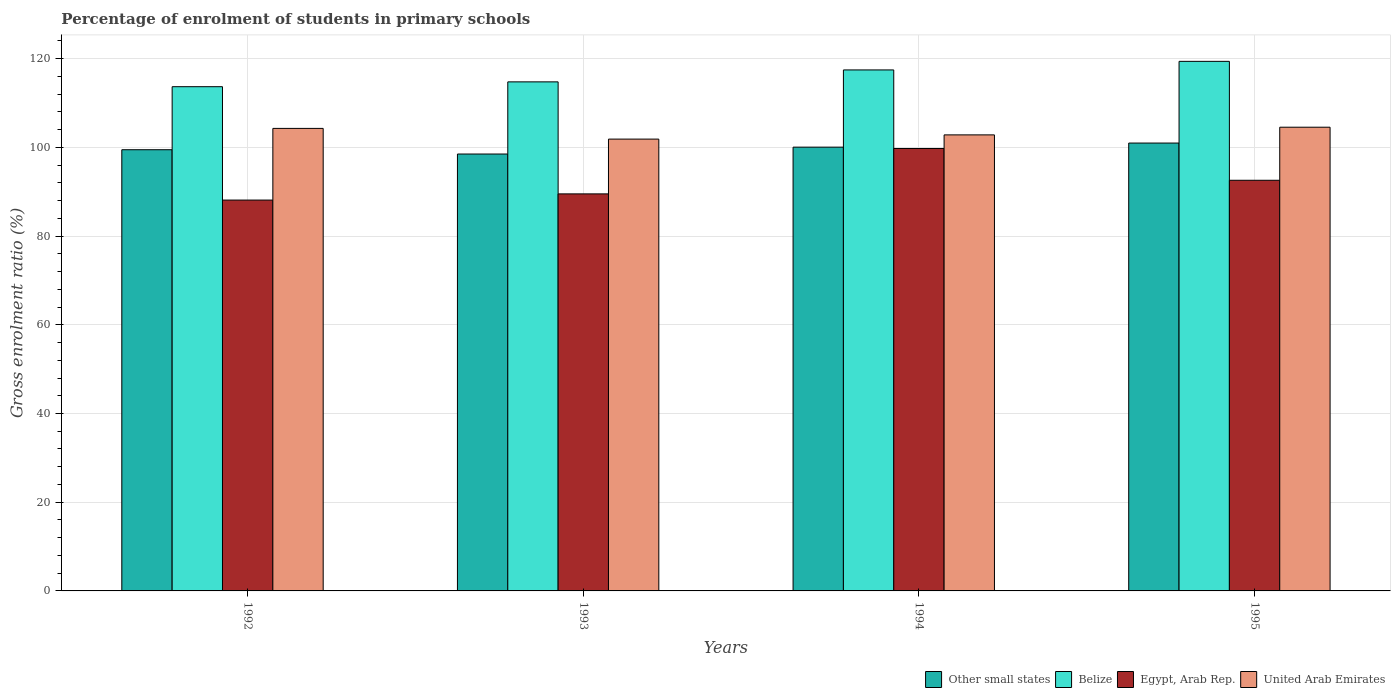How many bars are there on the 2nd tick from the left?
Provide a short and direct response. 4. What is the label of the 1st group of bars from the left?
Make the answer very short. 1992. In how many cases, is the number of bars for a given year not equal to the number of legend labels?
Your response must be concise. 0. What is the percentage of students enrolled in primary schools in Belize in 1995?
Your answer should be compact. 119.4. Across all years, what is the maximum percentage of students enrolled in primary schools in United Arab Emirates?
Keep it short and to the point. 104.55. Across all years, what is the minimum percentage of students enrolled in primary schools in Egypt, Arab Rep.?
Give a very brief answer. 88.12. In which year was the percentage of students enrolled in primary schools in Egypt, Arab Rep. minimum?
Your answer should be compact. 1992. What is the total percentage of students enrolled in primary schools in Egypt, Arab Rep. in the graph?
Your answer should be compact. 369.98. What is the difference between the percentage of students enrolled in primary schools in Egypt, Arab Rep. in 1992 and that in 1995?
Your answer should be very brief. -4.46. What is the difference between the percentage of students enrolled in primary schools in Egypt, Arab Rep. in 1992 and the percentage of students enrolled in primary schools in United Arab Emirates in 1993?
Give a very brief answer. -13.75. What is the average percentage of students enrolled in primary schools in Other small states per year?
Offer a terse response. 99.75. In the year 1994, what is the difference between the percentage of students enrolled in primary schools in Other small states and percentage of students enrolled in primary schools in Egypt, Arab Rep.?
Offer a terse response. 0.3. What is the ratio of the percentage of students enrolled in primary schools in Egypt, Arab Rep. in 1993 to that in 1994?
Provide a succinct answer. 0.9. Is the percentage of students enrolled in primary schools in Belize in 1993 less than that in 1994?
Offer a very short reply. Yes. Is the difference between the percentage of students enrolled in primary schools in Other small states in 1992 and 1994 greater than the difference between the percentage of students enrolled in primary schools in Egypt, Arab Rep. in 1992 and 1994?
Offer a very short reply. Yes. What is the difference between the highest and the second highest percentage of students enrolled in primary schools in United Arab Emirates?
Offer a terse response. 0.27. What is the difference between the highest and the lowest percentage of students enrolled in primary schools in Other small states?
Keep it short and to the point. 2.47. In how many years, is the percentage of students enrolled in primary schools in Other small states greater than the average percentage of students enrolled in primary schools in Other small states taken over all years?
Ensure brevity in your answer.  2. What does the 4th bar from the left in 1992 represents?
Ensure brevity in your answer.  United Arab Emirates. What does the 2nd bar from the right in 1995 represents?
Provide a short and direct response. Egypt, Arab Rep. Is it the case that in every year, the sum of the percentage of students enrolled in primary schools in Other small states and percentage of students enrolled in primary schools in United Arab Emirates is greater than the percentage of students enrolled in primary schools in Egypt, Arab Rep.?
Make the answer very short. Yes. How many bars are there?
Provide a short and direct response. 16. Does the graph contain any zero values?
Your answer should be compact. No. Does the graph contain grids?
Provide a succinct answer. Yes. Where does the legend appear in the graph?
Your response must be concise. Bottom right. How are the legend labels stacked?
Make the answer very short. Horizontal. What is the title of the graph?
Provide a short and direct response. Percentage of enrolment of students in primary schools. What is the Gross enrolment ratio (%) of Other small states in 1992?
Provide a short and direct response. 99.47. What is the Gross enrolment ratio (%) in Belize in 1992?
Provide a succinct answer. 113.68. What is the Gross enrolment ratio (%) in Egypt, Arab Rep. in 1992?
Your response must be concise. 88.12. What is the Gross enrolment ratio (%) in United Arab Emirates in 1992?
Your answer should be very brief. 104.28. What is the Gross enrolment ratio (%) in Other small states in 1993?
Offer a very short reply. 98.5. What is the Gross enrolment ratio (%) of Belize in 1993?
Offer a very short reply. 114.77. What is the Gross enrolment ratio (%) of Egypt, Arab Rep. in 1993?
Provide a short and direct response. 89.52. What is the Gross enrolment ratio (%) in United Arab Emirates in 1993?
Your answer should be very brief. 101.87. What is the Gross enrolment ratio (%) of Other small states in 1994?
Ensure brevity in your answer.  100.06. What is the Gross enrolment ratio (%) of Belize in 1994?
Offer a very short reply. 117.46. What is the Gross enrolment ratio (%) of Egypt, Arab Rep. in 1994?
Give a very brief answer. 99.75. What is the Gross enrolment ratio (%) in United Arab Emirates in 1994?
Ensure brevity in your answer.  102.82. What is the Gross enrolment ratio (%) in Other small states in 1995?
Give a very brief answer. 100.98. What is the Gross enrolment ratio (%) in Belize in 1995?
Offer a terse response. 119.4. What is the Gross enrolment ratio (%) in Egypt, Arab Rep. in 1995?
Provide a short and direct response. 92.59. What is the Gross enrolment ratio (%) in United Arab Emirates in 1995?
Offer a terse response. 104.55. Across all years, what is the maximum Gross enrolment ratio (%) of Other small states?
Your answer should be compact. 100.98. Across all years, what is the maximum Gross enrolment ratio (%) in Belize?
Provide a succinct answer. 119.4. Across all years, what is the maximum Gross enrolment ratio (%) of Egypt, Arab Rep.?
Offer a very short reply. 99.75. Across all years, what is the maximum Gross enrolment ratio (%) of United Arab Emirates?
Make the answer very short. 104.55. Across all years, what is the minimum Gross enrolment ratio (%) in Other small states?
Offer a very short reply. 98.5. Across all years, what is the minimum Gross enrolment ratio (%) of Belize?
Your response must be concise. 113.68. Across all years, what is the minimum Gross enrolment ratio (%) of Egypt, Arab Rep.?
Your answer should be compact. 88.12. Across all years, what is the minimum Gross enrolment ratio (%) in United Arab Emirates?
Make the answer very short. 101.87. What is the total Gross enrolment ratio (%) in Other small states in the graph?
Your response must be concise. 399.01. What is the total Gross enrolment ratio (%) of Belize in the graph?
Your response must be concise. 465.32. What is the total Gross enrolment ratio (%) of Egypt, Arab Rep. in the graph?
Ensure brevity in your answer.  369.98. What is the total Gross enrolment ratio (%) in United Arab Emirates in the graph?
Offer a terse response. 413.52. What is the difference between the Gross enrolment ratio (%) of Other small states in 1992 and that in 1993?
Your response must be concise. 0.97. What is the difference between the Gross enrolment ratio (%) of Belize in 1992 and that in 1993?
Provide a succinct answer. -1.09. What is the difference between the Gross enrolment ratio (%) in Egypt, Arab Rep. in 1992 and that in 1993?
Ensure brevity in your answer.  -1.4. What is the difference between the Gross enrolment ratio (%) in United Arab Emirates in 1992 and that in 1993?
Give a very brief answer. 2.41. What is the difference between the Gross enrolment ratio (%) of Other small states in 1992 and that in 1994?
Give a very brief answer. -0.58. What is the difference between the Gross enrolment ratio (%) in Belize in 1992 and that in 1994?
Make the answer very short. -3.78. What is the difference between the Gross enrolment ratio (%) in Egypt, Arab Rep. in 1992 and that in 1994?
Ensure brevity in your answer.  -11.63. What is the difference between the Gross enrolment ratio (%) in United Arab Emirates in 1992 and that in 1994?
Ensure brevity in your answer.  1.46. What is the difference between the Gross enrolment ratio (%) of Other small states in 1992 and that in 1995?
Keep it short and to the point. -1.5. What is the difference between the Gross enrolment ratio (%) of Belize in 1992 and that in 1995?
Provide a short and direct response. -5.72. What is the difference between the Gross enrolment ratio (%) of Egypt, Arab Rep. in 1992 and that in 1995?
Keep it short and to the point. -4.46. What is the difference between the Gross enrolment ratio (%) of United Arab Emirates in 1992 and that in 1995?
Make the answer very short. -0.27. What is the difference between the Gross enrolment ratio (%) of Other small states in 1993 and that in 1994?
Keep it short and to the point. -1.55. What is the difference between the Gross enrolment ratio (%) of Belize in 1993 and that in 1994?
Provide a short and direct response. -2.69. What is the difference between the Gross enrolment ratio (%) of Egypt, Arab Rep. in 1993 and that in 1994?
Make the answer very short. -10.23. What is the difference between the Gross enrolment ratio (%) in United Arab Emirates in 1993 and that in 1994?
Provide a short and direct response. -0.95. What is the difference between the Gross enrolment ratio (%) of Other small states in 1993 and that in 1995?
Offer a terse response. -2.47. What is the difference between the Gross enrolment ratio (%) of Belize in 1993 and that in 1995?
Offer a very short reply. -4.63. What is the difference between the Gross enrolment ratio (%) of Egypt, Arab Rep. in 1993 and that in 1995?
Provide a succinct answer. -3.07. What is the difference between the Gross enrolment ratio (%) of United Arab Emirates in 1993 and that in 1995?
Give a very brief answer. -2.68. What is the difference between the Gross enrolment ratio (%) in Other small states in 1994 and that in 1995?
Provide a short and direct response. -0.92. What is the difference between the Gross enrolment ratio (%) of Belize in 1994 and that in 1995?
Make the answer very short. -1.93. What is the difference between the Gross enrolment ratio (%) in Egypt, Arab Rep. in 1994 and that in 1995?
Your response must be concise. 7.17. What is the difference between the Gross enrolment ratio (%) of United Arab Emirates in 1994 and that in 1995?
Your answer should be very brief. -1.73. What is the difference between the Gross enrolment ratio (%) in Other small states in 1992 and the Gross enrolment ratio (%) in Belize in 1993?
Your answer should be very brief. -15.3. What is the difference between the Gross enrolment ratio (%) of Other small states in 1992 and the Gross enrolment ratio (%) of Egypt, Arab Rep. in 1993?
Keep it short and to the point. 9.95. What is the difference between the Gross enrolment ratio (%) of Other small states in 1992 and the Gross enrolment ratio (%) of United Arab Emirates in 1993?
Your answer should be very brief. -2.4. What is the difference between the Gross enrolment ratio (%) of Belize in 1992 and the Gross enrolment ratio (%) of Egypt, Arab Rep. in 1993?
Make the answer very short. 24.16. What is the difference between the Gross enrolment ratio (%) of Belize in 1992 and the Gross enrolment ratio (%) of United Arab Emirates in 1993?
Keep it short and to the point. 11.82. What is the difference between the Gross enrolment ratio (%) of Egypt, Arab Rep. in 1992 and the Gross enrolment ratio (%) of United Arab Emirates in 1993?
Offer a terse response. -13.75. What is the difference between the Gross enrolment ratio (%) of Other small states in 1992 and the Gross enrolment ratio (%) of Belize in 1994?
Offer a very short reply. -17.99. What is the difference between the Gross enrolment ratio (%) of Other small states in 1992 and the Gross enrolment ratio (%) of Egypt, Arab Rep. in 1994?
Ensure brevity in your answer.  -0.28. What is the difference between the Gross enrolment ratio (%) of Other small states in 1992 and the Gross enrolment ratio (%) of United Arab Emirates in 1994?
Your answer should be compact. -3.35. What is the difference between the Gross enrolment ratio (%) in Belize in 1992 and the Gross enrolment ratio (%) in Egypt, Arab Rep. in 1994?
Provide a short and direct response. 13.93. What is the difference between the Gross enrolment ratio (%) of Belize in 1992 and the Gross enrolment ratio (%) of United Arab Emirates in 1994?
Your response must be concise. 10.86. What is the difference between the Gross enrolment ratio (%) in Egypt, Arab Rep. in 1992 and the Gross enrolment ratio (%) in United Arab Emirates in 1994?
Your answer should be very brief. -14.7. What is the difference between the Gross enrolment ratio (%) in Other small states in 1992 and the Gross enrolment ratio (%) in Belize in 1995?
Provide a short and direct response. -19.93. What is the difference between the Gross enrolment ratio (%) in Other small states in 1992 and the Gross enrolment ratio (%) in Egypt, Arab Rep. in 1995?
Give a very brief answer. 6.89. What is the difference between the Gross enrolment ratio (%) of Other small states in 1992 and the Gross enrolment ratio (%) of United Arab Emirates in 1995?
Provide a short and direct response. -5.08. What is the difference between the Gross enrolment ratio (%) in Belize in 1992 and the Gross enrolment ratio (%) in Egypt, Arab Rep. in 1995?
Ensure brevity in your answer.  21.1. What is the difference between the Gross enrolment ratio (%) of Belize in 1992 and the Gross enrolment ratio (%) of United Arab Emirates in 1995?
Offer a very short reply. 9.13. What is the difference between the Gross enrolment ratio (%) in Egypt, Arab Rep. in 1992 and the Gross enrolment ratio (%) in United Arab Emirates in 1995?
Offer a very short reply. -16.43. What is the difference between the Gross enrolment ratio (%) in Other small states in 1993 and the Gross enrolment ratio (%) in Belize in 1994?
Make the answer very short. -18.96. What is the difference between the Gross enrolment ratio (%) of Other small states in 1993 and the Gross enrolment ratio (%) of Egypt, Arab Rep. in 1994?
Give a very brief answer. -1.25. What is the difference between the Gross enrolment ratio (%) in Other small states in 1993 and the Gross enrolment ratio (%) in United Arab Emirates in 1994?
Provide a succinct answer. -4.32. What is the difference between the Gross enrolment ratio (%) of Belize in 1993 and the Gross enrolment ratio (%) of Egypt, Arab Rep. in 1994?
Keep it short and to the point. 15.02. What is the difference between the Gross enrolment ratio (%) of Belize in 1993 and the Gross enrolment ratio (%) of United Arab Emirates in 1994?
Your answer should be very brief. 11.95. What is the difference between the Gross enrolment ratio (%) in Egypt, Arab Rep. in 1993 and the Gross enrolment ratio (%) in United Arab Emirates in 1994?
Offer a very short reply. -13.3. What is the difference between the Gross enrolment ratio (%) of Other small states in 1993 and the Gross enrolment ratio (%) of Belize in 1995?
Offer a terse response. -20.9. What is the difference between the Gross enrolment ratio (%) of Other small states in 1993 and the Gross enrolment ratio (%) of Egypt, Arab Rep. in 1995?
Your answer should be compact. 5.92. What is the difference between the Gross enrolment ratio (%) in Other small states in 1993 and the Gross enrolment ratio (%) in United Arab Emirates in 1995?
Provide a succinct answer. -6.05. What is the difference between the Gross enrolment ratio (%) of Belize in 1993 and the Gross enrolment ratio (%) of Egypt, Arab Rep. in 1995?
Your answer should be compact. 22.19. What is the difference between the Gross enrolment ratio (%) in Belize in 1993 and the Gross enrolment ratio (%) in United Arab Emirates in 1995?
Ensure brevity in your answer.  10.22. What is the difference between the Gross enrolment ratio (%) of Egypt, Arab Rep. in 1993 and the Gross enrolment ratio (%) of United Arab Emirates in 1995?
Make the answer very short. -15.03. What is the difference between the Gross enrolment ratio (%) in Other small states in 1994 and the Gross enrolment ratio (%) in Belize in 1995?
Offer a terse response. -19.34. What is the difference between the Gross enrolment ratio (%) of Other small states in 1994 and the Gross enrolment ratio (%) of Egypt, Arab Rep. in 1995?
Give a very brief answer. 7.47. What is the difference between the Gross enrolment ratio (%) in Other small states in 1994 and the Gross enrolment ratio (%) in United Arab Emirates in 1995?
Your answer should be compact. -4.49. What is the difference between the Gross enrolment ratio (%) in Belize in 1994 and the Gross enrolment ratio (%) in Egypt, Arab Rep. in 1995?
Give a very brief answer. 24.88. What is the difference between the Gross enrolment ratio (%) in Belize in 1994 and the Gross enrolment ratio (%) in United Arab Emirates in 1995?
Offer a terse response. 12.92. What is the difference between the Gross enrolment ratio (%) of Egypt, Arab Rep. in 1994 and the Gross enrolment ratio (%) of United Arab Emirates in 1995?
Make the answer very short. -4.8. What is the average Gross enrolment ratio (%) of Other small states per year?
Keep it short and to the point. 99.75. What is the average Gross enrolment ratio (%) of Belize per year?
Offer a terse response. 116.33. What is the average Gross enrolment ratio (%) in Egypt, Arab Rep. per year?
Your response must be concise. 92.49. What is the average Gross enrolment ratio (%) in United Arab Emirates per year?
Offer a terse response. 103.38. In the year 1992, what is the difference between the Gross enrolment ratio (%) of Other small states and Gross enrolment ratio (%) of Belize?
Keep it short and to the point. -14.21. In the year 1992, what is the difference between the Gross enrolment ratio (%) of Other small states and Gross enrolment ratio (%) of Egypt, Arab Rep.?
Keep it short and to the point. 11.35. In the year 1992, what is the difference between the Gross enrolment ratio (%) in Other small states and Gross enrolment ratio (%) in United Arab Emirates?
Give a very brief answer. -4.81. In the year 1992, what is the difference between the Gross enrolment ratio (%) of Belize and Gross enrolment ratio (%) of Egypt, Arab Rep.?
Your answer should be compact. 25.56. In the year 1992, what is the difference between the Gross enrolment ratio (%) in Belize and Gross enrolment ratio (%) in United Arab Emirates?
Make the answer very short. 9.4. In the year 1992, what is the difference between the Gross enrolment ratio (%) in Egypt, Arab Rep. and Gross enrolment ratio (%) in United Arab Emirates?
Keep it short and to the point. -16.16. In the year 1993, what is the difference between the Gross enrolment ratio (%) in Other small states and Gross enrolment ratio (%) in Belize?
Your response must be concise. -16.27. In the year 1993, what is the difference between the Gross enrolment ratio (%) in Other small states and Gross enrolment ratio (%) in Egypt, Arab Rep.?
Give a very brief answer. 8.98. In the year 1993, what is the difference between the Gross enrolment ratio (%) in Other small states and Gross enrolment ratio (%) in United Arab Emirates?
Keep it short and to the point. -3.36. In the year 1993, what is the difference between the Gross enrolment ratio (%) of Belize and Gross enrolment ratio (%) of Egypt, Arab Rep.?
Your answer should be compact. 25.25. In the year 1993, what is the difference between the Gross enrolment ratio (%) in Belize and Gross enrolment ratio (%) in United Arab Emirates?
Give a very brief answer. 12.9. In the year 1993, what is the difference between the Gross enrolment ratio (%) of Egypt, Arab Rep. and Gross enrolment ratio (%) of United Arab Emirates?
Your answer should be very brief. -12.35. In the year 1994, what is the difference between the Gross enrolment ratio (%) in Other small states and Gross enrolment ratio (%) in Belize?
Offer a very short reply. -17.41. In the year 1994, what is the difference between the Gross enrolment ratio (%) of Other small states and Gross enrolment ratio (%) of Egypt, Arab Rep.?
Your answer should be compact. 0.3. In the year 1994, what is the difference between the Gross enrolment ratio (%) in Other small states and Gross enrolment ratio (%) in United Arab Emirates?
Keep it short and to the point. -2.76. In the year 1994, what is the difference between the Gross enrolment ratio (%) of Belize and Gross enrolment ratio (%) of Egypt, Arab Rep.?
Offer a terse response. 17.71. In the year 1994, what is the difference between the Gross enrolment ratio (%) in Belize and Gross enrolment ratio (%) in United Arab Emirates?
Offer a terse response. 14.64. In the year 1994, what is the difference between the Gross enrolment ratio (%) of Egypt, Arab Rep. and Gross enrolment ratio (%) of United Arab Emirates?
Offer a very short reply. -3.07. In the year 1995, what is the difference between the Gross enrolment ratio (%) in Other small states and Gross enrolment ratio (%) in Belize?
Ensure brevity in your answer.  -18.42. In the year 1995, what is the difference between the Gross enrolment ratio (%) of Other small states and Gross enrolment ratio (%) of Egypt, Arab Rep.?
Your answer should be compact. 8.39. In the year 1995, what is the difference between the Gross enrolment ratio (%) in Other small states and Gross enrolment ratio (%) in United Arab Emirates?
Your response must be concise. -3.57. In the year 1995, what is the difference between the Gross enrolment ratio (%) in Belize and Gross enrolment ratio (%) in Egypt, Arab Rep.?
Keep it short and to the point. 26.81. In the year 1995, what is the difference between the Gross enrolment ratio (%) in Belize and Gross enrolment ratio (%) in United Arab Emirates?
Offer a terse response. 14.85. In the year 1995, what is the difference between the Gross enrolment ratio (%) in Egypt, Arab Rep. and Gross enrolment ratio (%) in United Arab Emirates?
Offer a terse response. -11.96. What is the ratio of the Gross enrolment ratio (%) of Other small states in 1992 to that in 1993?
Your answer should be compact. 1.01. What is the ratio of the Gross enrolment ratio (%) of Belize in 1992 to that in 1993?
Make the answer very short. 0.99. What is the ratio of the Gross enrolment ratio (%) in Egypt, Arab Rep. in 1992 to that in 1993?
Your answer should be compact. 0.98. What is the ratio of the Gross enrolment ratio (%) of United Arab Emirates in 1992 to that in 1993?
Your response must be concise. 1.02. What is the ratio of the Gross enrolment ratio (%) in Other small states in 1992 to that in 1994?
Your answer should be very brief. 0.99. What is the ratio of the Gross enrolment ratio (%) in Belize in 1992 to that in 1994?
Keep it short and to the point. 0.97. What is the ratio of the Gross enrolment ratio (%) in Egypt, Arab Rep. in 1992 to that in 1994?
Your answer should be compact. 0.88. What is the ratio of the Gross enrolment ratio (%) of United Arab Emirates in 1992 to that in 1994?
Provide a succinct answer. 1.01. What is the ratio of the Gross enrolment ratio (%) of Other small states in 1992 to that in 1995?
Keep it short and to the point. 0.99. What is the ratio of the Gross enrolment ratio (%) in Belize in 1992 to that in 1995?
Give a very brief answer. 0.95. What is the ratio of the Gross enrolment ratio (%) of Egypt, Arab Rep. in 1992 to that in 1995?
Ensure brevity in your answer.  0.95. What is the ratio of the Gross enrolment ratio (%) in Other small states in 1993 to that in 1994?
Give a very brief answer. 0.98. What is the ratio of the Gross enrolment ratio (%) of Belize in 1993 to that in 1994?
Your answer should be compact. 0.98. What is the ratio of the Gross enrolment ratio (%) of Egypt, Arab Rep. in 1993 to that in 1994?
Make the answer very short. 0.9. What is the ratio of the Gross enrolment ratio (%) of United Arab Emirates in 1993 to that in 1994?
Make the answer very short. 0.99. What is the ratio of the Gross enrolment ratio (%) in Other small states in 1993 to that in 1995?
Your answer should be compact. 0.98. What is the ratio of the Gross enrolment ratio (%) of Belize in 1993 to that in 1995?
Keep it short and to the point. 0.96. What is the ratio of the Gross enrolment ratio (%) in Egypt, Arab Rep. in 1993 to that in 1995?
Ensure brevity in your answer.  0.97. What is the ratio of the Gross enrolment ratio (%) in United Arab Emirates in 1993 to that in 1995?
Make the answer very short. 0.97. What is the ratio of the Gross enrolment ratio (%) of Other small states in 1994 to that in 1995?
Make the answer very short. 0.99. What is the ratio of the Gross enrolment ratio (%) of Belize in 1994 to that in 1995?
Provide a short and direct response. 0.98. What is the ratio of the Gross enrolment ratio (%) of Egypt, Arab Rep. in 1994 to that in 1995?
Offer a terse response. 1.08. What is the ratio of the Gross enrolment ratio (%) in United Arab Emirates in 1994 to that in 1995?
Provide a short and direct response. 0.98. What is the difference between the highest and the second highest Gross enrolment ratio (%) of Other small states?
Provide a short and direct response. 0.92. What is the difference between the highest and the second highest Gross enrolment ratio (%) in Belize?
Give a very brief answer. 1.93. What is the difference between the highest and the second highest Gross enrolment ratio (%) of Egypt, Arab Rep.?
Offer a very short reply. 7.17. What is the difference between the highest and the second highest Gross enrolment ratio (%) in United Arab Emirates?
Give a very brief answer. 0.27. What is the difference between the highest and the lowest Gross enrolment ratio (%) in Other small states?
Your answer should be very brief. 2.47. What is the difference between the highest and the lowest Gross enrolment ratio (%) in Belize?
Your response must be concise. 5.72. What is the difference between the highest and the lowest Gross enrolment ratio (%) of Egypt, Arab Rep.?
Make the answer very short. 11.63. What is the difference between the highest and the lowest Gross enrolment ratio (%) of United Arab Emirates?
Keep it short and to the point. 2.68. 